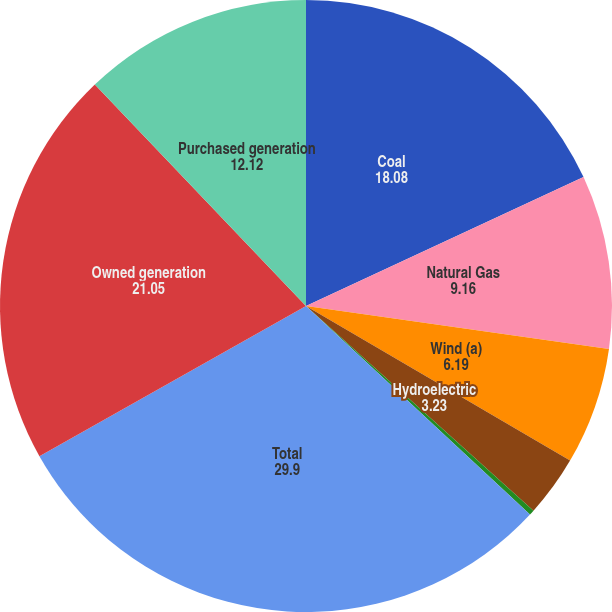Convert chart. <chart><loc_0><loc_0><loc_500><loc_500><pie_chart><fcel>Coal<fcel>Natural Gas<fcel>Wind (a)<fcel>Hydroelectric<fcel>Other (b)<fcel>Total<fcel>Owned generation<fcel>Purchased generation<nl><fcel>18.08%<fcel>9.16%<fcel>6.19%<fcel>3.23%<fcel>0.27%<fcel>29.9%<fcel>21.05%<fcel>12.12%<nl></chart> 